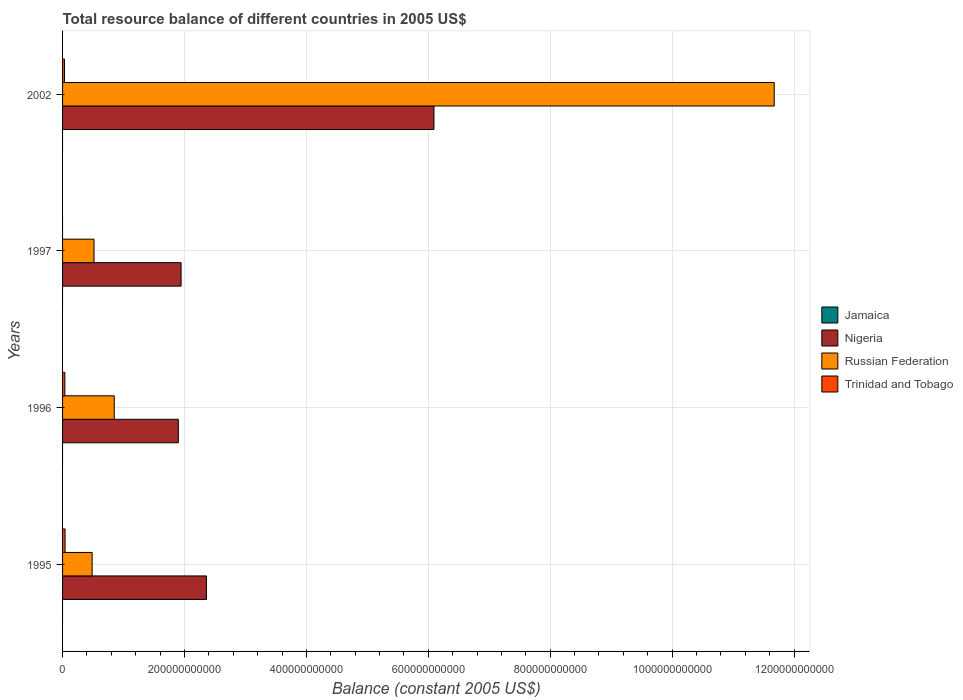What is the total resource balance in Russian Federation in 1997?
Your answer should be very brief. 5.16e+1. Across all years, what is the maximum total resource balance in Trinidad and Tobago?
Your response must be concise. 4.09e+09. What is the total total resource balance in Jamaica in the graph?
Ensure brevity in your answer.  0. What is the difference between the total resource balance in Nigeria in 1996 and that in 1997?
Make the answer very short. -4.48e+09. What is the difference between the total resource balance in Nigeria in 1997 and the total resource balance in Jamaica in 1995?
Keep it short and to the point. 1.94e+11. What is the average total resource balance in Jamaica per year?
Offer a very short reply. 0. In the year 1996, what is the difference between the total resource balance in Nigeria and total resource balance in Trinidad and Tobago?
Your answer should be compact. 1.86e+11. What is the ratio of the total resource balance in Nigeria in 1995 to that in 1996?
Make the answer very short. 1.24. What is the difference between the highest and the second highest total resource balance in Nigeria?
Make the answer very short. 3.73e+11. What is the difference between the highest and the lowest total resource balance in Trinidad and Tobago?
Your response must be concise. 4.09e+09. How many bars are there?
Ensure brevity in your answer.  11. Are all the bars in the graph horizontal?
Keep it short and to the point. Yes. What is the difference between two consecutive major ticks on the X-axis?
Your answer should be very brief. 2.00e+11. Are the values on the major ticks of X-axis written in scientific E-notation?
Offer a terse response. No. Does the graph contain grids?
Offer a terse response. Yes. How many legend labels are there?
Ensure brevity in your answer.  4. How are the legend labels stacked?
Offer a very short reply. Vertical. What is the title of the graph?
Make the answer very short. Total resource balance of different countries in 2005 US$. Does "Austria" appear as one of the legend labels in the graph?
Give a very brief answer. No. What is the label or title of the X-axis?
Your answer should be compact. Balance (constant 2005 US$). What is the Balance (constant 2005 US$) in Jamaica in 1995?
Provide a short and direct response. 0. What is the Balance (constant 2005 US$) in Nigeria in 1995?
Your answer should be compact. 2.36e+11. What is the Balance (constant 2005 US$) of Russian Federation in 1995?
Provide a succinct answer. 4.85e+1. What is the Balance (constant 2005 US$) of Trinidad and Tobago in 1995?
Offer a very short reply. 4.09e+09. What is the Balance (constant 2005 US$) in Jamaica in 1996?
Offer a terse response. 0. What is the Balance (constant 2005 US$) of Nigeria in 1996?
Your answer should be very brief. 1.90e+11. What is the Balance (constant 2005 US$) in Russian Federation in 1996?
Provide a short and direct response. 8.48e+1. What is the Balance (constant 2005 US$) in Trinidad and Tobago in 1996?
Your answer should be compact. 3.76e+09. What is the Balance (constant 2005 US$) in Jamaica in 1997?
Give a very brief answer. 0. What is the Balance (constant 2005 US$) in Nigeria in 1997?
Make the answer very short. 1.94e+11. What is the Balance (constant 2005 US$) in Russian Federation in 1997?
Provide a succinct answer. 5.16e+1. What is the Balance (constant 2005 US$) of Jamaica in 2002?
Keep it short and to the point. 0. What is the Balance (constant 2005 US$) of Nigeria in 2002?
Provide a succinct answer. 6.09e+11. What is the Balance (constant 2005 US$) of Russian Federation in 2002?
Your answer should be compact. 1.17e+12. What is the Balance (constant 2005 US$) in Trinidad and Tobago in 2002?
Give a very brief answer. 3.14e+09. Across all years, what is the maximum Balance (constant 2005 US$) in Nigeria?
Offer a terse response. 6.09e+11. Across all years, what is the maximum Balance (constant 2005 US$) of Russian Federation?
Make the answer very short. 1.17e+12. Across all years, what is the maximum Balance (constant 2005 US$) of Trinidad and Tobago?
Your answer should be very brief. 4.09e+09. Across all years, what is the minimum Balance (constant 2005 US$) of Nigeria?
Offer a terse response. 1.90e+11. Across all years, what is the minimum Balance (constant 2005 US$) in Russian Federation?
Your answer should be compact. 4.85e+1. Across all years, what is the minimum Balance (constant 2005 US$) of Trinidad and Tobago?
Make the answer very short. 0. What is the total Balance (constant 2005 US$) of Nigeria in the graph?
Your response must be concise. 1.23e+12. What is the total Balance (constant 2005 US$) of Russian Federation in the graph?
Offer a very short reply. 1.35e+12. What is the total Balance (constant 2005 US$) of Trinidad and Tobago in the graph?
Offer a very short reply. 1.10e+1. What is the difference between the Balance (constant 2005 US$) of Nigeria in 1995 and that in 1996?
Make the answer very short. 4.62e+1. What is the difference between the Balance (constant 2005 US$) of Russian Federation in 1995 and that in 1996?
Your answer should be compact. -3.63e+1. What is the difference between the Balance (constant 2005 US$) in Trinidad and Tobago in 1995 and that in 1996?
Your answer should be very brief. 3.34e+08. What is the difference between the Balance (constant 2005 US$) of Nigeria in 1995 and that in 1997?
Ensure brevity in your answer.  4.17e+1. What is the difference between the Balance (constant 2005 US$) in Russian Federation in 1995 and that in 1997?
Give a very brief answer. -3.10e+09. What is the difference between the Balance (constant 2005 US$) in Nigeria in 1995 and that in 2002?
Keep it short and to the point. -3.73e+11. What is the difference between the Balance (constant 2005 US$) in Russian Federation in 1995 and that in 2002?
Provide a succinct answer. -1.12e+12. What is the difference between the Balance (constant 2005 US$) of Trinidad and Tobago in 1995 and that in 2002?
Make the answer very short. 9.57e+08. What is the difference between the Balance (constant 2005 US$) in Nigeria in 1996 and that in 1997?
Provide a short and direct response. -4.48e+09. What is the difference between the Balance (constant 2005 US$) of Russian Federation in 1996 and that in 1997?
Your response must be concise. 3.32e+1. What is the difference between the Balance (constant 2005 US$) of Nigeria in 1996 and that in 2002?
Offer a terse response. -4.19e+11. What is the difference between the Balance (constant 2005 US$) of Russian Federation in 1996 and that in 2002?
Offer a very short reply. -1.08e+12. What is the difference between the Balance (constant 2005 US$) in Trinidad and Tobago in 1996 and that in 2002?
Provide a short and direct response. 6.23e+08. What is the difference between the Balance (constant 2005 US$) in Nigeria in 1997 and that in 2002?
Give a very brief answer. -4.15e+11. What is the difference between the Balance (constant 2005 US$) in Russian Federation in 1997 and that in 2002?
Your answer should be compact. -1.12e+12. What is the difference between the Balance (constant 2005 US$) of Nigeria in 1995 and the Balance (constant 2005 US$) of Russian Federation in 1996?
Keep it short and to the point. 1.51e+11. What is the difference between the Balance (constant 2005 US$) of Nigeria in 1995 and the Balance (constant 2005 US$) of Trinidad and Tobago in 1996?
Offer a terse response. 2.32e+11. What is the difference between the Balance (constant 2005 US$) of Russian Federation in 1995 and the Balance (constant 2005 US$) of Trinidad and Tobago in 1996?
Provide a short and direct response. 4.47e+1. What is the difference between the Balance (constant 2005 US$) of Nigeria in 1995 and the Balance (constant 2005 US$) of Russian Federation in 1997?
Provide a short and direct response. 1.85e+11. What is the difference between the Balance (constant 2005 US$) of Nigeria in 1995 and the Balance (constant 2005 US$) of Russian Federation in 2002?
Keep it short and to the point. -9.31e+11. What is the difference between the Balance (constant 2005 US$) in Nigeria in 1995 and the Balance (constant 2005 US$) in Trinidad and Tobago in 2002?
Give a very brief answer. 2.33e+11. What is the difference between the Balance (constant 2005 US$) in Russian Federation in 1995 and the Balance (constant 2005 US$) in Trinidad and Tobago in 2002?
Make the answer very short. 4.54e+1. What is the difference between the Balance (constant 2005 US$) of Nigeria in 1996 and the Balance (constant 2005 US$) of Russian Federation in 1997?
Keep it short and to the point. 1.38e+11. What is the difference between the Balance (constant 2005 US$) of Nigeria in 1996 and the Balance (constant 2005 US$) of Russian Federation in 2002?
Ensure brevity in your answer.  -9.78e+11. What is the difference between the Balance (constant 2005 US$) in Nigeria in 1996 and the Balance (constant 2005 US$) in Trinidad and Tobago in 2002?
Provide a short and direct response. 1.87e+11. What is the difference between the Balance (constant 2005 US$) of Russian Federation in 1996 and the Balance (constant 2005 US$) of Trinidad and Tobago in 2002?
Provide a succinct answer. 8.17e+1. What is the difference between the Balance (constant 2005 US$) of Nigeria in 1997 and the Balance (constant 2005 US$) of Russian Federation in 2002?
Provide a succinct answer. -9.73e+11. What is the difference between the Balance (constant 2005 US$) in Nigeria in 1997 and the Balance (constant 2005 US$) in Trinidad and Tobago in 2002?
Make the answer very short. 1.91e+11. What is the difference between the Balance (constant 2005 US$) of Russian Federation in 1997 and the Balance (constant 2005 US$) of Trinidad and Tobago in 2002?
Make the answer very short. 4.85e+1. What is the average Balance (constant 2005 US$) of Nigeria per year?
Keep it short and to the point. 3.07e+11. What is the average Balance (constant 2005 US$) in Russian Federation per year?
Give a very brief answer. 3.38e+11. What is the average Balance (constant 2005 US$) in Trinidad and Tobago per year?
Offer a terse response. 2.75e+09. In the year 1995, what is the difference between the Balance (constant 2005 US$) in Nigeria and Balance (constant 2005 US$) in Russian Federation?
Your response must be concise. 1.88e+11. In the year 1995, what is the difference between the Balance (constant 2005 US$) of Nigeria and Balance (constant 2005 US$) of Trinidad and Tobago?
Provide a short and direct response. 2.32e+11. In the year 1995, what is the difference between the Balance (constant 2005 US$) of Russian Federation and Balance (constant 2005 US$) of Trinidad and Tobago?
Your response must be concise. 4.44e+1. In the year 1996, what is the difference between the Balance (constant 2005 US$) of Nigeria and Balance (constant 2005 US$) of Russian Federation?
Provide a short and direct response. 1.05e+11. In the year 1996, what is the difference between the Balance (constant 2005 US$) in Nigeria and Balance (constant 2005 US$) in Trinidad and Tobago?
Your answer should be compact. 1.86e+11. In the year 1996, what is the difference between the Balance (constant 2005 US$) of Russian Federation and Balance (constant 2005 US$) of Trinidad and Tobago?
Make the answer very short. 8.10e+1. In the year 1997, what is the difference between the Balance (constant 2005 US$) in Nigeria and Balance (constant 2005 US$) in Russian Federation?
Ensure brevity in your answer.  1.43e+11. In the year 2002, what is the difference between the Balance (constant 2005 US$) in Nigeria and Balance (constant 2005 US$) in Russian Federation?
Offer a very short reply. -5.58e+11. In the year 2002, what is the difference between the Balance (constant 2005 US$) of Nigeria and Balance (constant 2005 US$) of Trinidad and Tobago?
Offer a terse response. 6.06e+11. In the year 2002, what is the difference between the Balance (constant 2005 US$) in Russian Federation and Balance (constant 2005 US$) in Trinidad and Tobago?
Your response must be concise. 1.16e+12. What is the ratio of the Balance (constant 2005 US$) of Nigeria in 1995 to that in 1996?
Offer a very short reply. 1.24. What is the ratio of the Balance (constant 2005 US$) in Russian Federation in 1995 to that in 1996?
Offer a very short reply. 0.57. What is the ratio of the Balance (constant 2005 US$) in Trinidad and Tobago in 1995 to that in 1996?
Offer a very short reply. 1.09. What is the ratio of the Balance (constant 2005 US$) in Nigeria in 1995 to that in 1997?
Offer a very short reply. 1.21. What is the ratio of the Balance (constant 2005 US$) of Russian Federation in 1995 to that in 1997?
Offer a very short reply. 0.94. What is the ratio of the Balance (constant 2005 US$) in Nigeria in 1995 to that in 2002?
Provide a short and direct response. 0.39. What is the ratio of the Balance (constant 2005 US$) in Russian Federation in 1995 to that in 2002?
Your response must be concise. 0.04. What is the ratio of the Balance (constant 2005 US$) of Trinidad and Tobago in 1995 to that in 2002?
Offer a terse response. 1.31. What is the ratio of the Balance (constant 2005 US$) in Nigeria in 1996 to that in 1997?
Give a very brief answer. 0.98. What is the ratio of the Balance (constant 2005 US$) of Russian Federation in 1996 to that in 1997?
Offer a terse response. 1.64. What is the ratio of the Balance (constant 2005 US$) of Nigeria in 1996 to that in 2002?
Provide a short and direct response. 0.31. What is the ratio of the Balance (constant 2005 US$) of Russian Federation in 1996 to that in 2002?
Offer a very short reply. 0.07. What is the ratio of the Balance (constant 2005 US$) in Trinidad and Tobago in 1996 to that in 2002?
Provide a short and direct response. 1.2. What is the ratio of the Balance (constant 2005 US$) of Nigeria in 1997 to that in 2002?
Your answer should be compact. 0.32. What is the ratio of the Balance (constant 2005 US$) of Russian Federation in 1997 to that in 2002?
Offer a very short reply. 0.04. What is the difference between the highest and the second highest Balance (constant 2005 US$) of Nigeria?
Offer a terse response. 3.73e+11. What is the difference between the highest and the second highest Balance (constant 2005 US$) in Russian Federation?
Your response must be concise. 1.08e+12. What is the difference between the highest and the second highest Balance (constant 2005 US$) in Trinidad and Tobago?
Provide a succinct answer. 3.34e+08. What is the difference between the highest and the lowest Balance (constant 2005 US$) in Nigeria?
Offer a very short reply. 4.19e+11. What is the difference between the highest and the lowest Balance (constant 2005 US$) of Russian Federation?
Make the answer very short. 1.12e+12. What is the difference between the highest and the lowest Balance (constant 2005 US$) of Trinidad and Tobago?
Your answer should be very brief. 4.09e+09. 